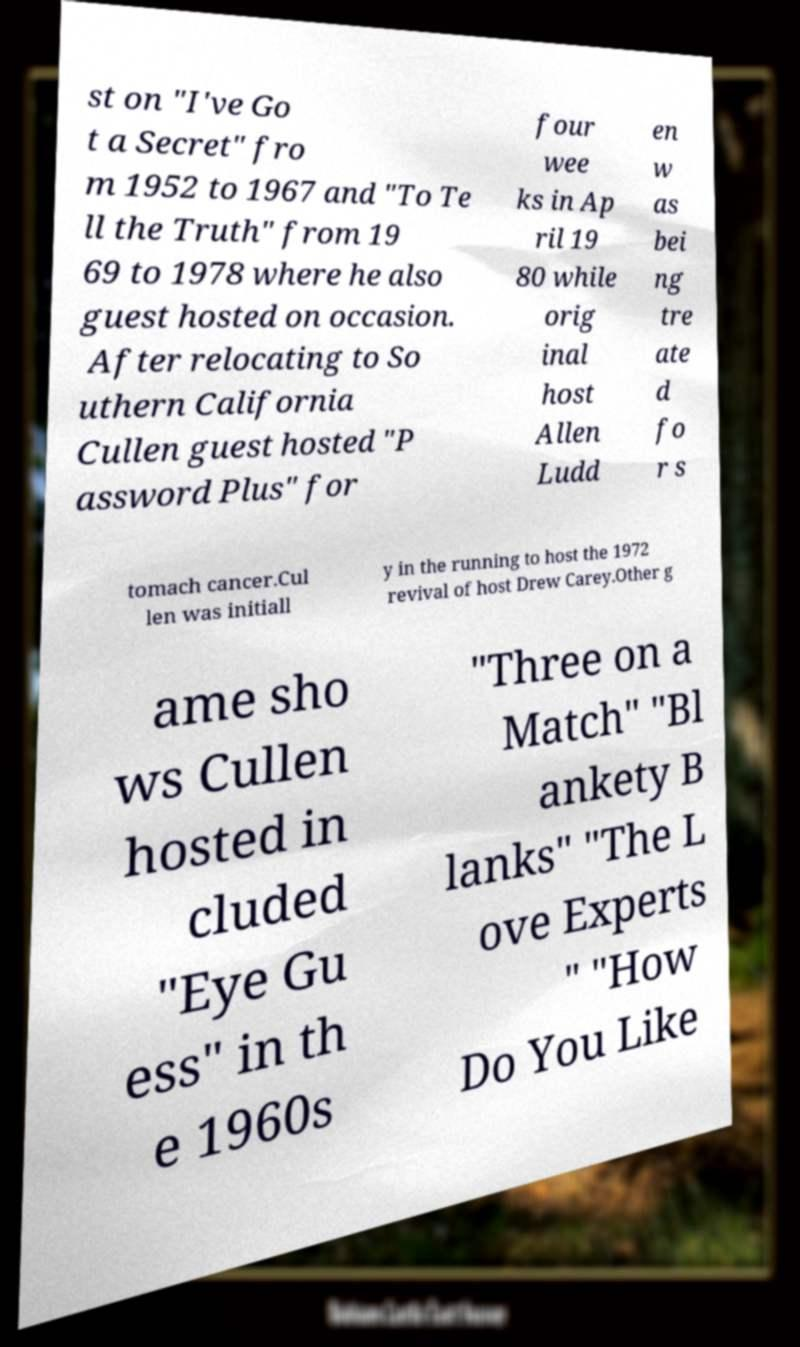I need the written content from this picture converted into text. Can you do that? st on "I've Go t a Secret" fro m 1952 to 1967 and "To Te ll the Truth" from 19 69 to 1978 where he also guest hosted on occasion. After relocating to So uthern California Cullen guest hosted "P assword Plus" for four wee ks in Ap ril 19 80 while orig inal host Allen Ludd en w as bei ng tre ate d fo r s tomach cancer.Cul len was initiall y in the running to host the 1972 revival of host Drew Carey.Other g ame sho ws Cullen hosted in cluded "Eye Gu ess" in th e 1960s "Three on a Match" "Bl ankety B lanks" "The L ove Experts " "How Do You Like 